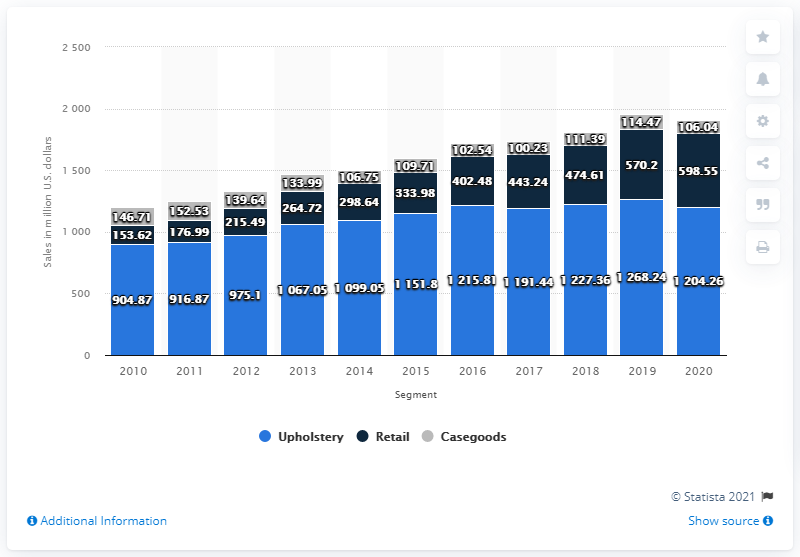Highlight a few significant elements in this photo. La-Z-Boy's casegoods segment had a value of approximately $106.04 million in 2020. 